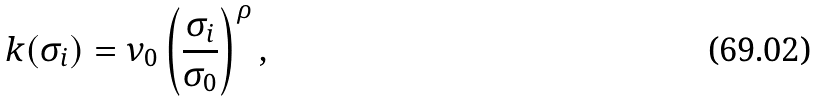Convert formula to latex. <formula><loc_0><loc_0><loc_500><loc_500>k ( \sigma _ { i } ) = \nu _ { 0 } \left ( \frac { \sigma _ { i } } { \sigma _ { 0 } } \right ) ^ { \rho } ,</formula> 